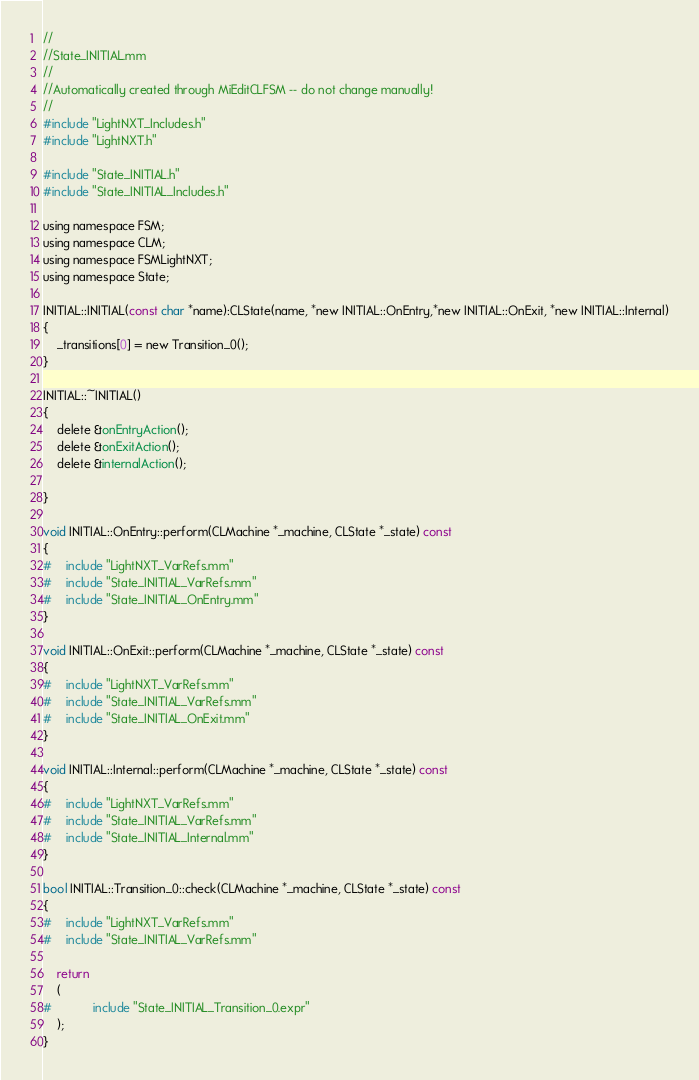<code> <loc_0><loc_0><loc_500><loc_500><_ObjectiveC_>//
//State_INITIAL.mm
//
//Automatically created through MiEditCLFSM -- do not change manually!
//
#include "LightNXT_Includes.h"
#include "LightNXT.h"

#include "State_INITIAL.h"
#include "State_INITIAL_Includes.h"

using namespace FSM;
using namespace CLM;
using namespace FSMLightNXT;
using namespace State;

INITIAL::INITIAL(const char *name):CLState(name, *new INITIAL::OnEntry,*new INITIAL::OnExit, *new INITIAL::Internal)
{
	_transitions[0] = new Transition_0();
}

INITIAL::~INITIAL()
{
	delete &onEntryAction();
	delete &onExitAction();
	delete &internalAction();

}

void INITIAL::OnEntry::perform(CLMachine *_machine, CLState *_state) const
{
#	include "LightNXT_VarRefs.mm"
#	include "State_INITIAL_VarRefs.mm"
#	include "State_INITIAL_OnEntry.mm"
}

void INITIAL::OnExit::perform(CLMachine *_machine, CLState *_state) const
{
#	include "LightNXT_VarRefs.mm"
#	include "State_INITIAL_VarRefs.mm"
#	include "State_INITIAL_OnExit.mm"
}

void INITIAL::Internal::perform(CLMachine *_machine, CLState *_state) const
{
#	include "LightNXT_VarRefs.mm"
#	include "State_INITIAL_VarRefs.mm"
#	include "State_INITIAL_Internal.mm"
}

bool INITIAL::Transition_0::check(CLMachine *_machine, CLState *_state) const
{
#	include "LightNXT_VarRefs.mm"
#	include "State_INITIAL_VarRefs.mm"

	return
	(
#			include "State_INITIAL_Transition_0.expr"
	);
}


</code> 